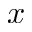Convert formula to latex. <formula><loc_0><loc_0><loc_500><loc_500>x</formula> 